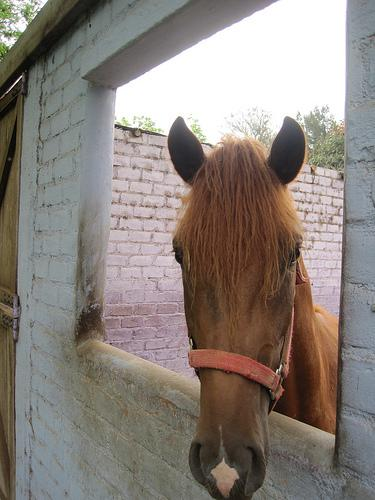Question: what animal is this?
Choices:
A. Dog.
B. Horse.
C. Cat.
D. Bear.
Answer with the letter. Answer: B Question: what is on the horse's face?
Choices:
A. Eyes.
B. Hair.
C. Bridle.
D. Flies.
Answer with the letter. Answer: C Question: how does the horse hear?
Choices:
A. Brain.
B. Ear drum.
C. Ears.
D. Sound.
Answer with the letter. Answer: C Question: where is this horse at?
Choices:
A. Farm.
B. Woods.
C. Barn.
D. Stable.
Answer with the letter. Answer: D Question: why can't you see his legs?
Choices:
A. Wall.
B. It's under the blankets.
C. The dog is sitting on his legs.
D. He lost them in Iraq.
Answer with the letter. Answer: A Question: where is he looking?
Choices:
A. Over his shoulder.
B. Towards the water.
C. At camera.
D. Towards the car.
Answer with the letter. Answer: C Question: how does he get out?
Choices:
A. Through the window.
B. The door.
C. Through the hole.
D. By crawling on the ground.
Answer with the letter. Answer: B Question: what color is the spot on his nose?
Choices:
A. Yellow.
B. Red.
C. Blue.
D. Pink.
Answer with the letter. Answer: D 